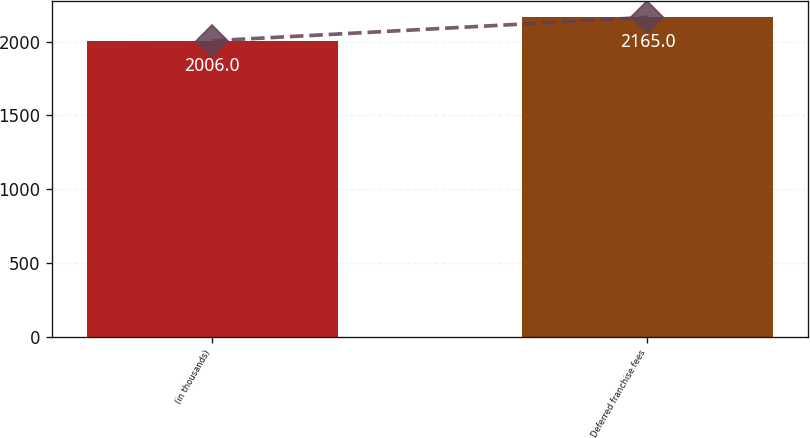<chart> <loc_0><loc_0><loc_500><loc_500><bar_chart><fcel>(in thousands)<fcel>Deferred franchise fees<nl><fcel>2006<fcel>2165<nl></chart> 